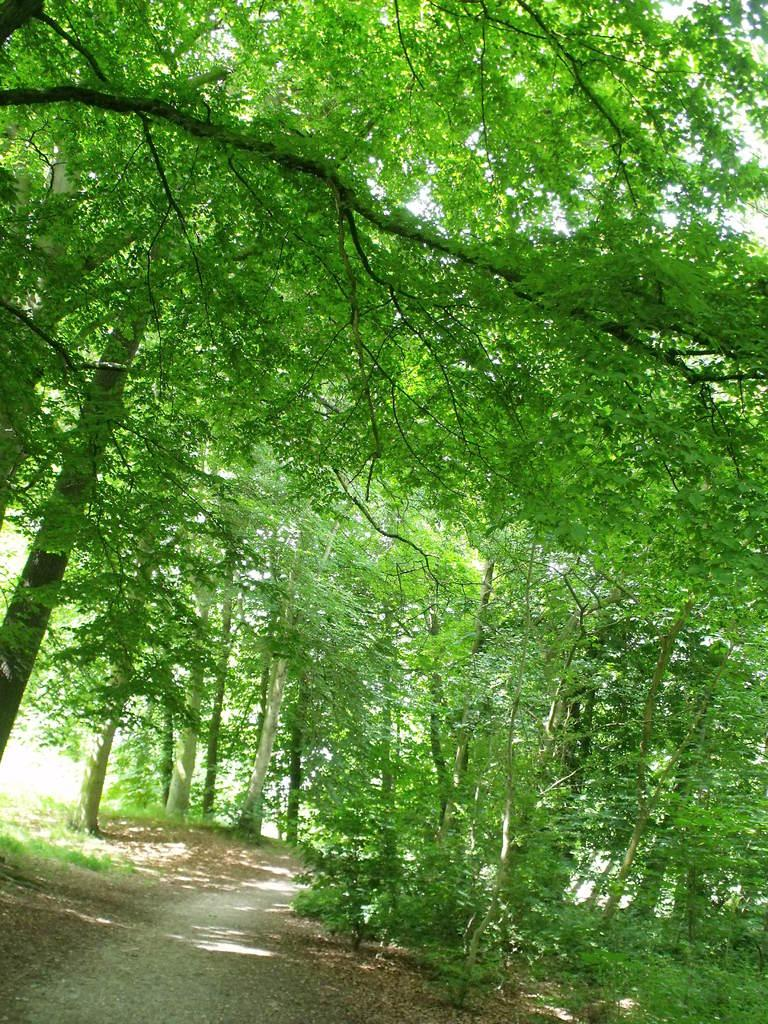What can be seen at the bottom of the image? The ground is visible in the image. What type of natural environment is depicted in the background? There are trees in the background of the image. What type of tail can be seen on the trees in the image? There are no tails visible in the image, as the trees do not have tails. Is there a fire hydrant present in the image? There is no mention of a fire hydrant in the provided facts, so it cannot be determined if one is present in the image. What type of club might be associated with the trees in the image? There is no club mentioned or depicted in the image, so it cannot be determined if one is associated with the trees. 